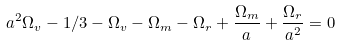<formula> <loc_0><loc_0><loc_500><loc_500>a ^ { 2 } \Omega _ { v } - 1 / 3 - \Omega _ { v } - \Omega _ { m } - \Omega _ { r } + \frac { \Omega _ { m } } { a } + \frac { \Omega _ { r } } { a ^ { 2 } } = 0</formula> 